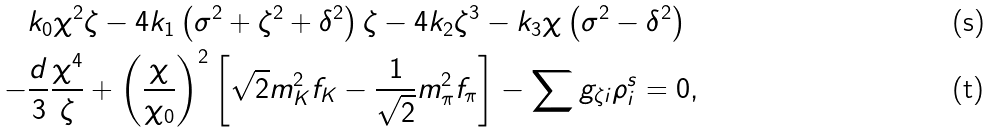<formula> <loc_0><loc_0><loc_500><loc_500>& k _ { 0 } \chi ^ { 2 } \zeta - 4 k _ { 1 } \left ( \sigma ^ { 2 } + \zeta ^ { 2 } + \delta ^ { 2 } \right ) \zeta - 4 k _ { 2 } \zeta ^ { 3 } - k _ { 3 } \chi \left ( \sigma ^ { 2 } - \delta ^ { 2 } \right ) \\ - & \frac { d } { 3 } \frac { \chi ^ { 4 } } { \zeta } + \left ( \frac { \chi } { \chi _ { 0 } } \right ) ^ { 2 } \left [ \sqrt { 2 } m _ { K } ^ { 2 } f _ { K } - \frac { 1 } { \sqrt { 2 } } m _ { \pi } ^ { 2 } f _ { \pi } \right ] - \sum g _ { \zeta i } \rho _ { i } ^ { s } = 0 ,</formula> 